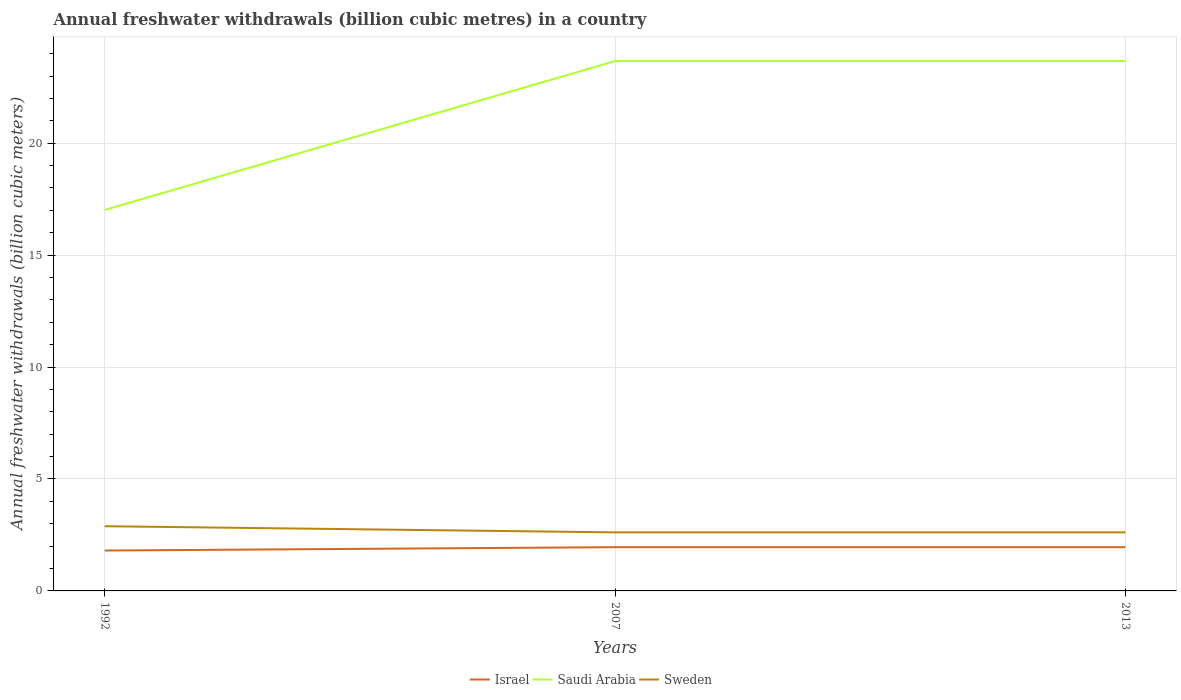How many different coloured lines are there?
Give a very brief answer. 3. Does the line corresponding to Saudi Arabia intersect with the line corresponding to Sweden?
Give a very brief answer. No. Across all years, what is the maximum annual freshwater withdrawals in Sweden?
Offer a very short reply. 2.62. What is the total annual freshwater withdrawals in Israel in the graph?
Give a very brief answer. 0. What is the difference between the highest and the second highest annual freshwater withdrawals in Sweden?
Give a very brief answer. 0.27. Is the annual freshwater withdrawals in Saudi Arabia strictly greater than the annual freshwater withdrawals in Israel over the years?
Keep it short and to the point. No. Are the values on the major ticks of Y-axis written in scientific E-notation?
Keep it short and to the point. No. Does the graph contain grids?
Make the answer very short. Yes. Where does the legend appear in the graph?
Your response must be concise. Bottom center. How many legend labels are there?
Offer a very short reply. 3. What is the title of the graph?
Your answer should be very brief. Annual freshwater withdrawals (billion cubic metres) in a country. What is the label or title of the Y-axis?
Ensure brevity in your answer.  Annual freshwater withdrawals (billion cubic meters). What is the Annual freshwater withdrawals (billion cubic meters) in Israel in 1992?
Ensure brevity in your answer.  1.8. What is the Annual freshwater withdrawals (billion cubic meters) in Saudi Arabia in 1992?
Your answer should be compact. 17.02. What is the Annual freshwater withdrawals (billion cubic meters) in Sweden in 1992?
Your response must be concise. 2.89. What is the Annual freshwater withdrawals (billion cubic meters) in Israel in 2007?
Your answer should be compact. 1.95. What is the Annual freshwater withdrawals (billion cubic meters) of Saudi Arabia in 2007?
Your answer should be compact. 23.67. What is the Annual freshwater withdrawals (billion cubic meters) in Sweden in 2007?
Make the answer very short. 2.62. What is the Annual freshwater withdrawals (billion cubic meters) in Israel in 2013?
Make the answer very short. 1.95. What is the Annual freshwater withdrawals (billion cubic meters) in Saudi Arabia in 2013?
Your answer should be very brief. 23.67. What is the Annual freshwater withdrawals (billion cubic meters) of Sweden in 2013?
Your response must be concise. 2.62. Across all years, what is the maximum Annual freshwater withdrawals (billion cubic meters) in Israel?
Offer a very short reply. 1.95. Across all years, what is the maximum Annual freshwater withdrawals (billion cubic meters) of Saudi Arabia?
Provide a succinct answer. 23.67. Across all years, what is the maximum Annual freshwater withdrawals (billion cubic meters) of Sweden?
Offer a very short reply. 2.89. Across all years, what is the minimum Annual freshwater withdrawals (billion cubic meters) of Israel?
Make the answer very short. 1.8. Across all years, what is the minimum Annual freshwater withdrawals (billion cubic meters) of Saudi Arabia?
Your response must be concise. 17.02. Across all years, what is the minimum Annual freshwater withdrawals (billion cubic meters) in Sweden?
Your response must be concise. 2.62. What is the total Annual freshwater withdrawals (billion cubic meters) of Israel in the graph?
Your answer should be very brief. 5.71. What is the total Annual freshwater withdrawals (billion cubic meters) of Saudi Arabia in the graph?
Your response must be concise. 64.36. What is the total Annual freshwater withdrawals (billion cubic meters) in Sweden in the graph?
Ensure brevity in your answer.  8.12. What is the difference between the Annual freshwater withdrawals (billion cubic meters) in Saudi Arabia in 1992 and that in 2007?
Provide a succinct answer. -6.65. What is the difference between the Annual freshwater withdrawals (billion cubic meters) of Sweden in 1992 and that in 2007?
Offer a very short reply. 0.27. What is the difference between the Annual freshwater withdrawals (billion cubic meters) of Saudi Arabia in 1992 and that in 2013?
Your answer should be very brief. -6.65. What is the difference between the Annual freshwater withdrawals (billion cubic meters) in Sweden in 1992 and that in 2013?
Ensure brevity in your answer.  0.27. What is the difference between the Annual freshwater withdrawals (billion cubic meters) in Israel in 1992 and the Annual freshwater withdrawals (billion cubic meters) in Saudi Arabia in 2007?
Your answer should be compact. -21.87. What is the difference between the Annual freshwater withdrawals (billion cubic meters) of Israel in 1992 and the Annual freshwater withdrawals (billion cubic meters) of Sweden in 2007?
Your answer should be compact. -0.81. What is the difference between the Annual freshwater withdrawals (billion cubic meters) in Saudi Arabia in 1992 and the Annual freshwater withdrawals (billion cubic meters) in Sweden in 2007?
Make the answer very short. 14.4. What is the difference between the Annual freshwater withdrawals (billion cubic meters) of Israel in 1992 and the Annual freshwater withdrawals (billion cubic meters) of Saudi Arabia in 2013?
Ensure brevity in your answer.  -21.87. What is the difference between the Annual freshwater withdrawals (billion cubic meters) of Israel in 1992 and the Annual freshwater withdrawals (billion cubic meters) of Sweden in 2013?
Give a very brief answer. -0.81. What is the difference between the Annual freshwater withdrawals (billion cubic meters) of Saudi Arabia in 1992 and the Annual freshwater withdrawals (billion cubic meters) of Sweden in 2013?
Your answer should be compact. 14.4. What is the difference between the Annual freshwater withdrawals (billion cubic meters) of Israel in 2007 and the Annual freshwater withdrawals (billion cubic meters) of Saudi Arabia in 2013?
Ensure brevity in your answer.  -21.72. What is the difference between the Annual freshwater withdrawals (billion cubic meters) in Israel in 2007 and the Annual freshwater withdrawals (billion cubic meters) in Sweden in 2013?
Give a very brief answer. -0.66. What is the difference between the Annual freshwater withdrawals (billion cubic meters) in Saudi Arabia in 2007 and the Annual freshwater withdrawals (billion cubic meters) in Sweden in 2013?
Make the answer very short. 21.05. What is the average Annual freshwater withdrawals (billion cubic meters) in Israel per year?
Provide a succinct answer. 1.9. What is the average Annual freshwater withdrawals (billion cubic meters) of Saudi Arabia per year?
Provide a short and direct response. 21.45. What is the average Annual freshwater withdrawals (billion cubic meters) of Sweden per year?
Offer a terse response. 2.71. In the year 1992, what is the difference between the Annual freshwater withdrawals (billion cubic meters) in Israel and Annual freshwater withdrawals (billion cubic meters) in Saudi Arabia?
Give a very brief answer. -15.22. In the year 1992, what is the difference between the Annual freshwater withdrawals (billion cubic meters) of Israel and Annual freshwater withdrawals (billion cubic meters) of Sweden?
Offer a very short reply. -1.09. In the year 1992, what is the difference between the Annual freshwater withdrawals (billion cubic meters) in Saudi Arabia and Annual freshwater withdrawals (billion cubic meters) in Sweden?
Your answer should be compact. 14.13. In the year 2007, what is the difference between the Annual freshwater withdrawals (billion cubic meters) in Israel and Annual freshwater withdrawals (billion cubic meters) in Saudi Arabia?
Your answer should be very brief. -21.72. In the year 2007, what is the difference between the Annual freshwater withdrawals (billion cubic meters) of Israel and Annual freshwater withdrawals (billion cubic meters) of Sweden?
Make the answer very short. -0.66. In the year 2007, what is the difference between the Annual freshwater withdrawals (billion cubic meters) of Saudi Arabia and Annual freshwater withdrawals (billion cubic meters) of Sweden?
Offer a terse response. 21.05. In the year 2013, what is the difference between the Annual freshwater withdrawals (billion cubic meters) in Israel and Annual freshwater withdrawals (billion cubic meters) in Saudi Arabia?
Offer a very short reply. -21.72. In the year 2013, what is the difference between the Annual freshwater withdrawals (billion cubic meters) of Israel and Annual freshwater withdrawals (billion cubic meters) of Sweden?
Your answer should be very brief. -0.66. In the year 2013, what is the difference between the Annual freshwater withdrawals (billion cubic meters) of Saudi Arabia and Annual freshwater withdrawals (billion cubic meters) of Sweden?
Give a very brief answer. 21.05. What is the ratio of the Annual freshwater withdrawals (billion cubic meters) in Israel in 1992 to that in 2007?
Provide a short and direct response. 0.92. What is the ratio of the Annual freshwater withdrawals (billion cubic meters) of Saudi Arabia in 1992 to that in 2007?
Provide a succinct answer. 0.72. What is the ratio of the Annual freshwater withdrawals (billion cubic meters) in Sweden in 1992 to that in 2007?
Ensure brevity in your answer.  1.1. What is the ratio of the Annual freshwater withdrawals (billion cubic meters) of Israel in 1992 to that in 2013?
Provide a succinct answer. 0.92. What is the ratio of the Annual freshwater withdrawals (billion cubic meters) of Saudi Arabia in 1992 to that in 2013?
Your response must be concise. 0.72. What is the ratio of the Annual freshwater withdrawals (billion cubic meters) of Sweden in 1992 to that in 2013?
Ensure brevity in your answer.  1.1. What is the ratio of the Annual freshwater withdrawals (billion cubic meters) in Israel in 2007 to that in 2013?
Ensure brevity in your answer.  1. What is the ratio of the Annual freshwater withdrawals (billion cubic meters) of Saudi Arabia in 2007 to that in 2013?
Your answer should be very brief. 1. What is the difference between the highest and the second highest Annual freshwater withdrawals (billion cubic meters) in Israel?
Your response must be concise. 0. What is the difference between the highest and the second highest Annual freshwater withdrawals (billion cubic meters) in Saudi Arabia?
Offer a very short reply. 0. What is the difference between the highest and the second highest Annual freshwater withdrawals (billion cubic meters) in Sweden?
Your answer should be compact. 0.27. What is the difference between the highest and the lowest Annual freshwater withdrawals (billion cubic meters) of Israel?
Provide a succinct answer. 0.15. What is the difference between the highest and the lowest Annual freshwater withdrawals (billion cubic meters) in Saudi Arabia?
Offer a very short reply. 6.65. What is the difference between the highest and the lowest Annual freshwater withdrawals (billion cubic meters) in Sweden?
Give a very brief answer. 0.27. 